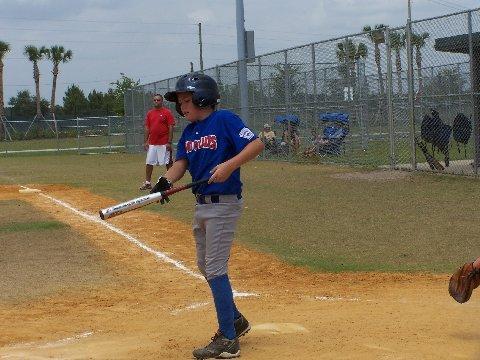How many baby elephants are pictured?
Give a very brief answer. 0. 